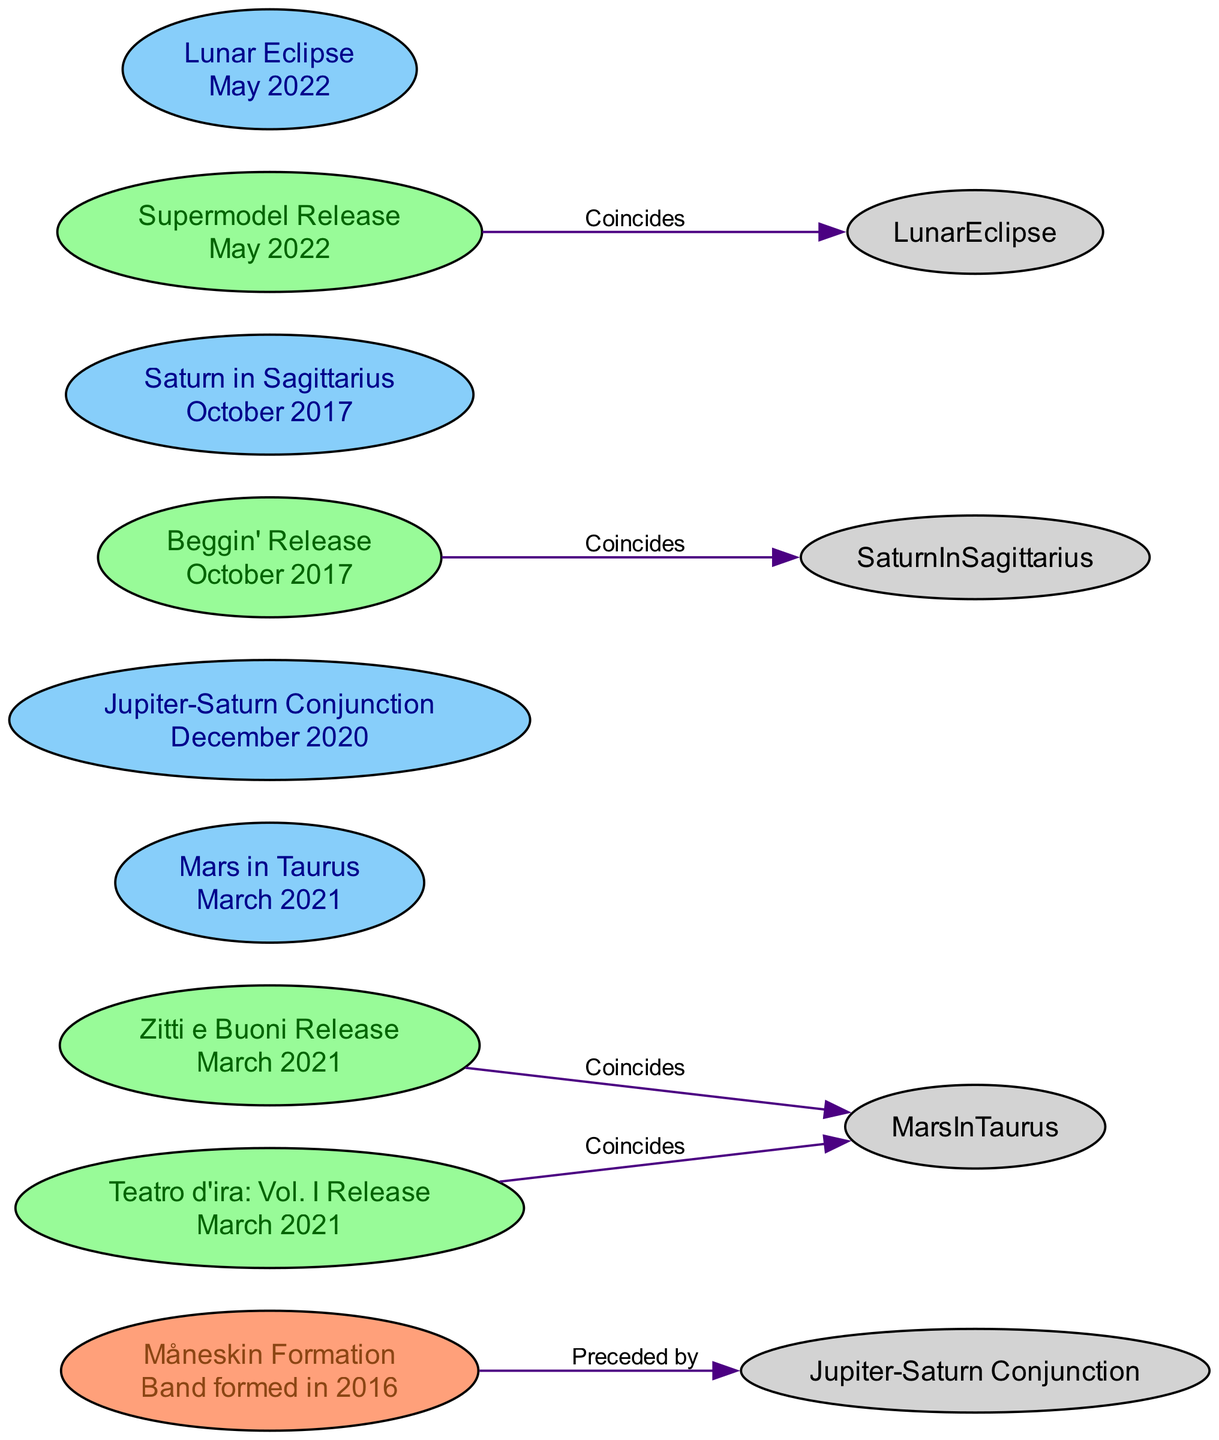What is the release date of "Zitti e Buoni"? According to the diagram, "Zitti e Buoni Release" is labeled with "March 2021", indicating this is the time it was released.
Answer: March 2021 How many major album releases are shown in the diagram? By counting the nodes related to album releases, we find four: "Zitti e Buoni Release", "Teatro d'ira: Vol. I Release", "Beggin' Release", and "Supermodel Release".
Answer: 4 What astrological event coincides with "Supermodel Release"? The diagram shows an edge connecting "Supermodel Release" to "Lunar Eclipse" with a label "Coincides", indicating that these two events happened at the same time.
Answer: Lunar Eclipse Which release is preceded by the "Jupiter-Saturn Conjunction"? The diagram indicates that "Måneskin Formation" is marked with a relationship labeled "Preceded by" with an edge pointing to "Jupiter-Saturn Conjunction". Hence, it shows that "Måneskin Formation" is related to and comes before this astrological event.
Answer: Måneskin Formation What is the relationship between the "Zitti e Buoni Release" and "Mars in Taurus"? The diagram connects "Zitti e Buoni Release" and "Mars in Taurus" with an edge labeled "Coincides", meaning both occurred simultaneously.
Answer: Coincides What was the first astrological event listed in the diagram? Looking through the nodes, the earliest astrological event is "Jupiter-Saturn Conjunction", which is dated December 2020, while the other events follow afterward.
Answer: Jupiter-Saturn Conjunction Which release correlates with "Beggin'"? The edge in the diagram shows that "BegginRelease" coinsides with "Saturn in Sagittarius", indicating this astrological event aligns with the release of that song.
Answer: Saturn in Sagittarius What is the timeframe of the last mentioned album release? The latest release indicated on the diagram is "Supermodel Release", dated May 2022, hence this is the most recent date shown.
Answer: May 2022 